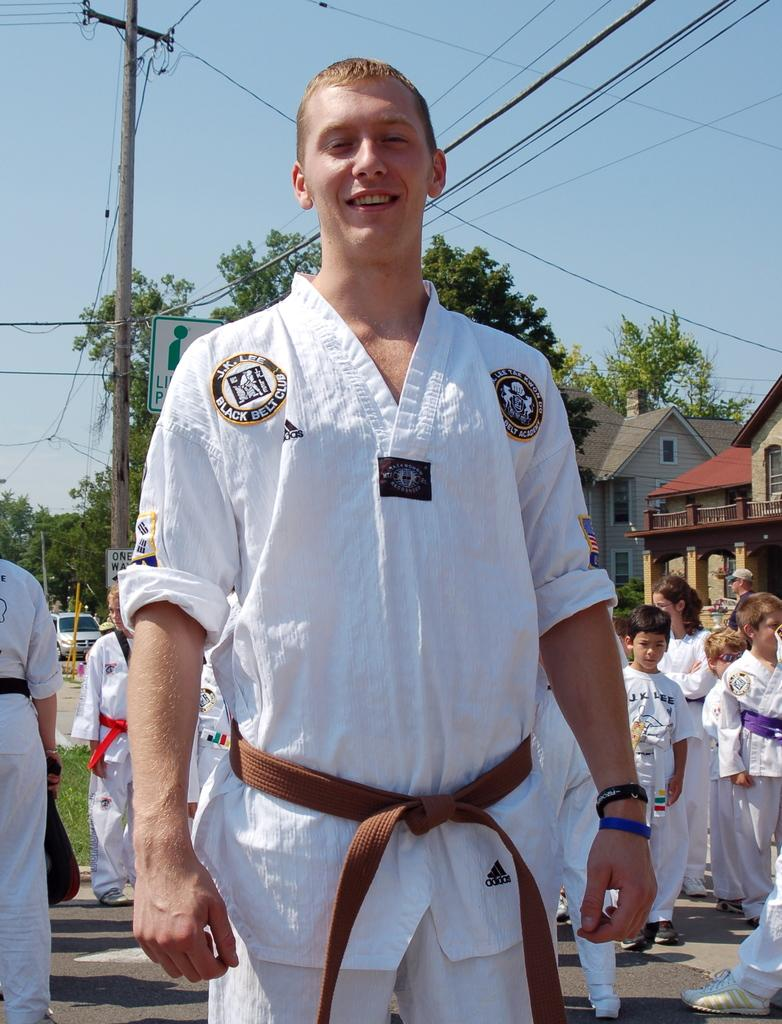Provide a one-sentence caption for the provided image. A young man is a member of the Black Belt Club. 